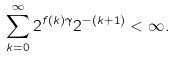<formula> <loc_0><loc_0><loc_500><loc_500>\sum _ { k = 0 } ^ { \infty } 2 ^ { f ( k ) \gamma } 2 ^ { - ( k + 1 ) } < \infty .</formula> 